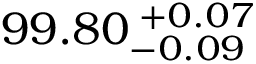<formula> <loc_0><loc_0><loc_500><loc_500>9 9 . 8 0 _ { - 0 . 0 9 } ^ { \, + 0 . 0 7 }</formula> 